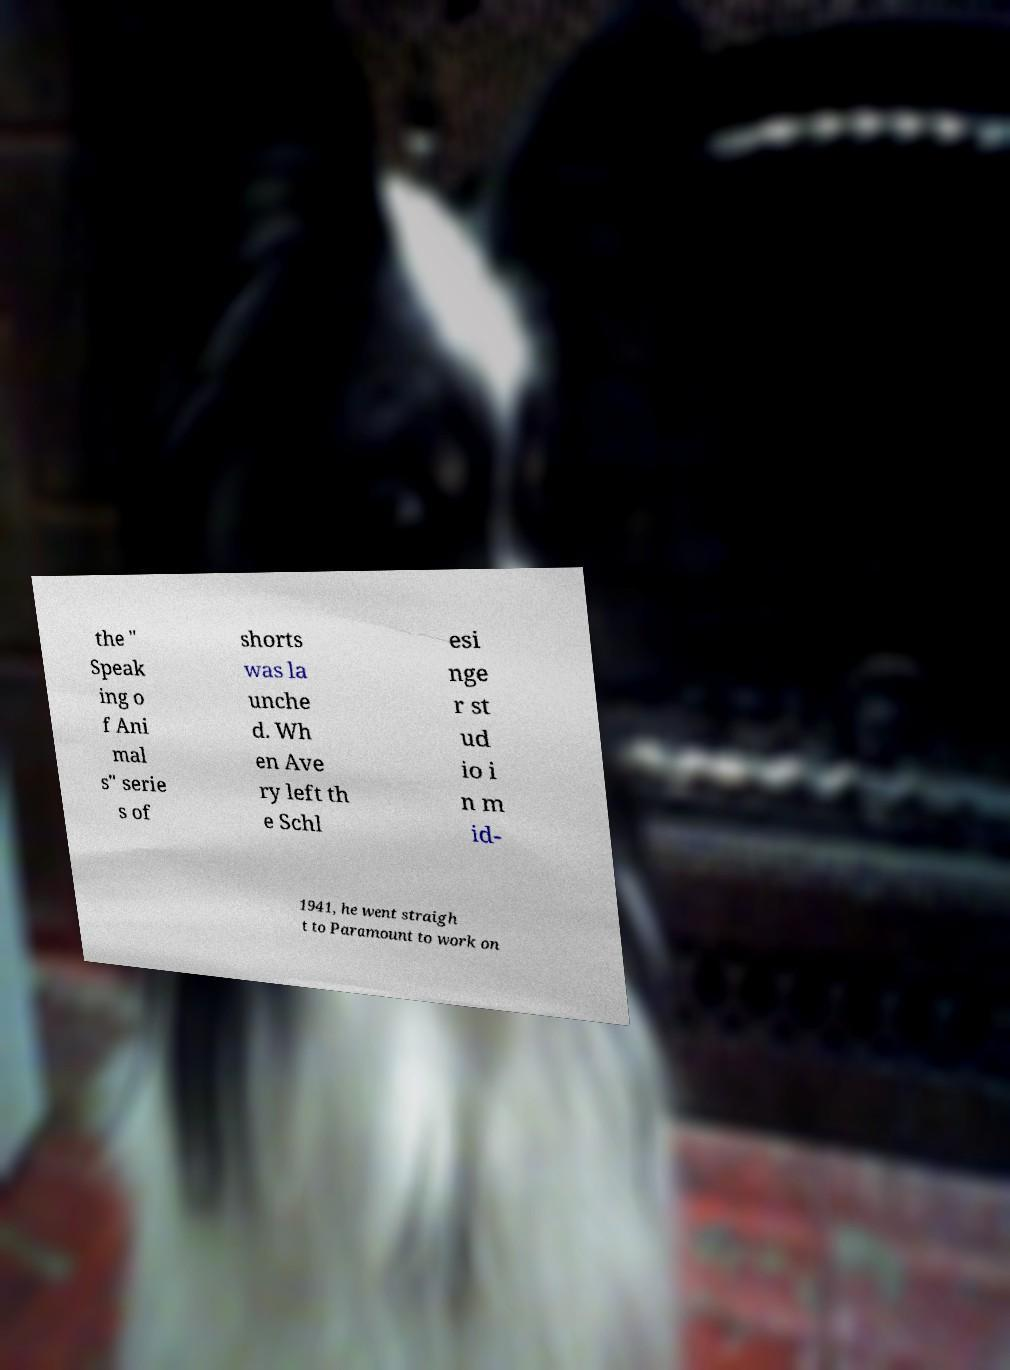Please identify and transcribe the text found in this image. the " Speak ing o f Ani mal s" serie s of shorts was la unche d. Wh en Ave ry left th e Schl esi nge r st ud io i n m id- 1941, he went straigh t to Paramount to work on 